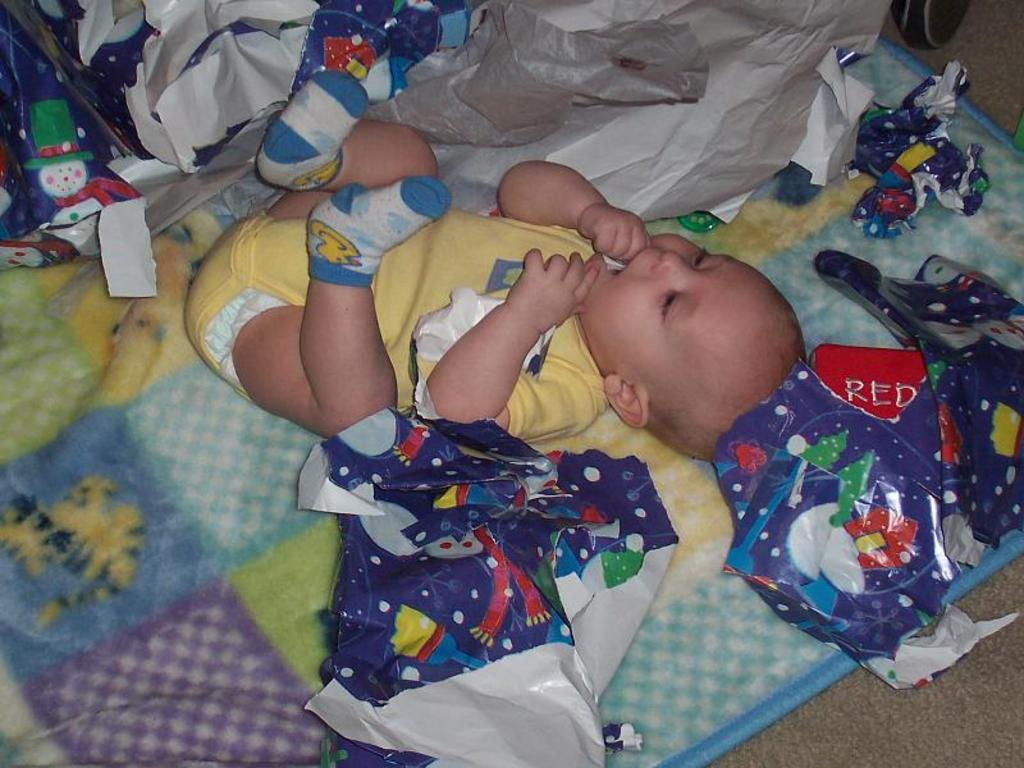What is the main subject of the picture? The main subject of the picture is an infant. What is the infant lying on? The infant is lying on a blanket. What is the infant wearing? The infant is wearing a yellow dress. What colors are the wrappers around the infant? The wrappers around the infant are blue and grey. How does the infant impulse the cork in the image? There is no cork present in the image, and the infant is not shown performing any actions related to impulsing a cork. 